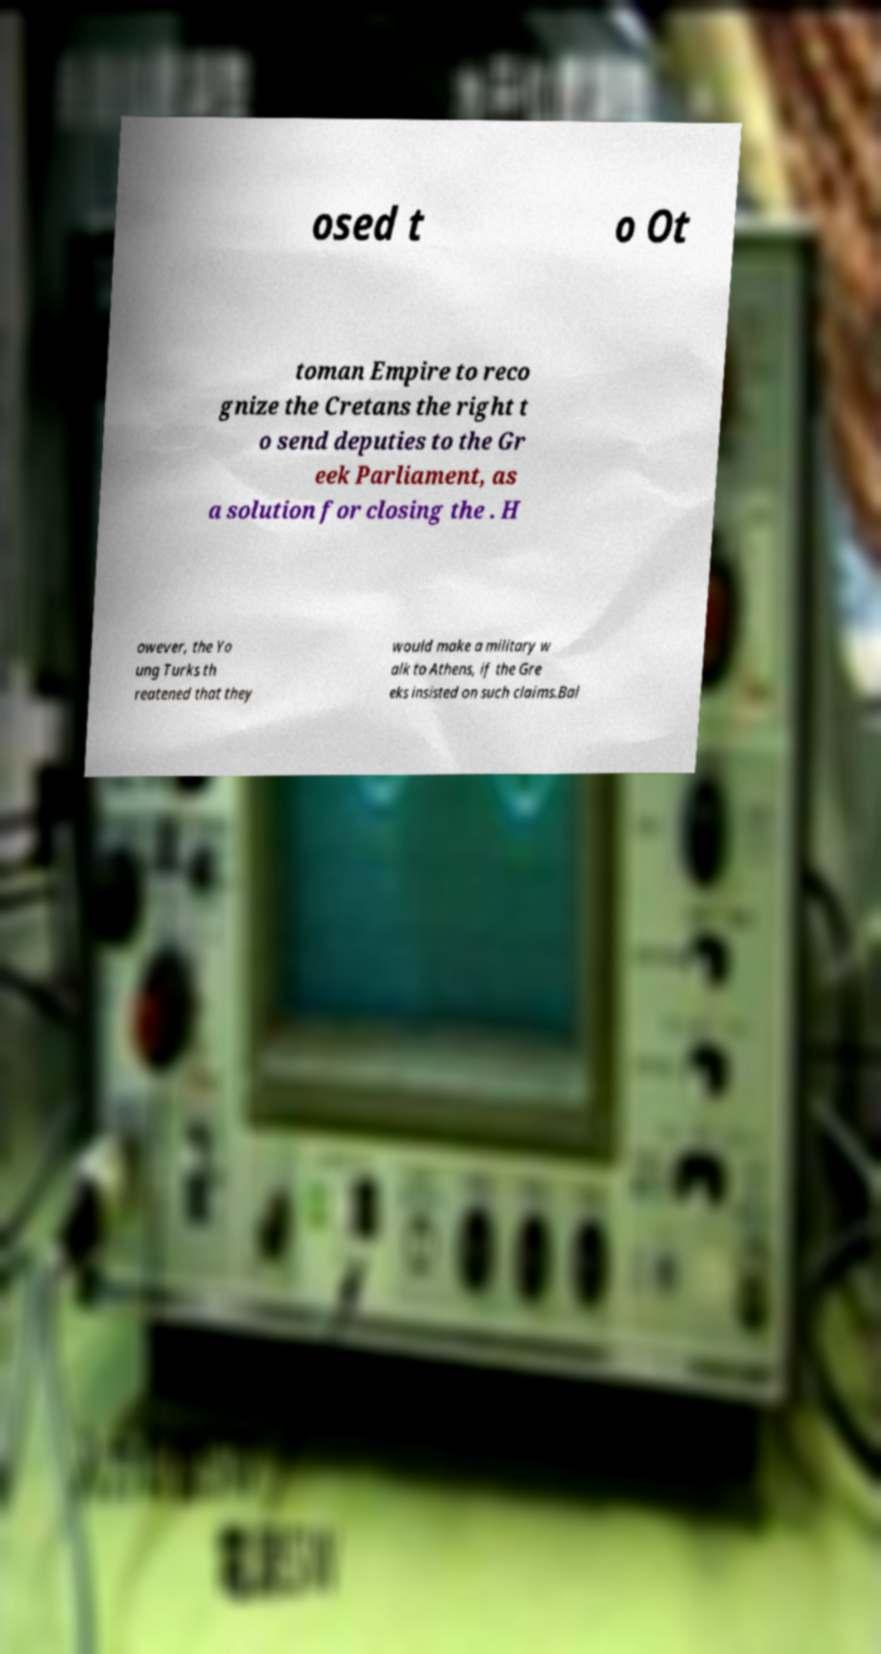Can you read and provide the text displayed in the image?This photo seems to have some interesting text. Can you extract and type it out for me? osed t o Ot toman Empire to reco gnize the Cretans the right t o send deputies to the Gr eek Parliament, as a solution for closing the . H owever, the Yo ung Turks th reatened that they would make a military w alk to Athens, if the Gre eks insisted on such claims.Bal 